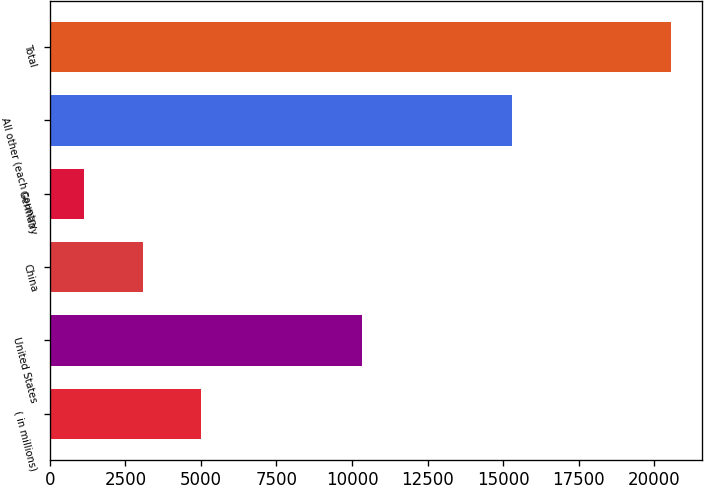<chart> <loc_0><loc_0><loc_500><loc_500><bar_chart><fcel>( in millions)<fcel>United States<fcel>China<fcel>Germany<fcel>All other (each country<fcel>Total<nl><fcel>5011.42<fcel>10321<fcel>3067.46<fcel>1123.5<fcel>15286.7<fcel>20563.1<nl></chart> 